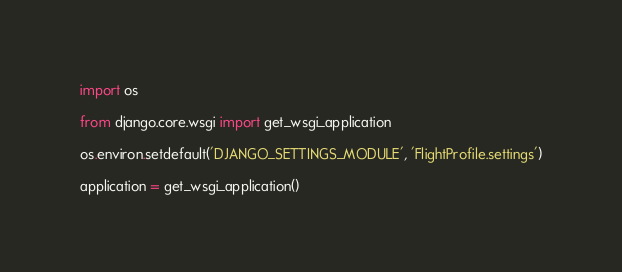Convert code to text. <code><loc_0><loc_0><loc_500><loc_500><_Python_>import os

from django.core.wsgi import get_wsgi_application

os.environ.setdefault('DJANGO_SETTINGS_MODULE', 'FlightProfile.settings')

application = get_wsgi_application()
</code> 